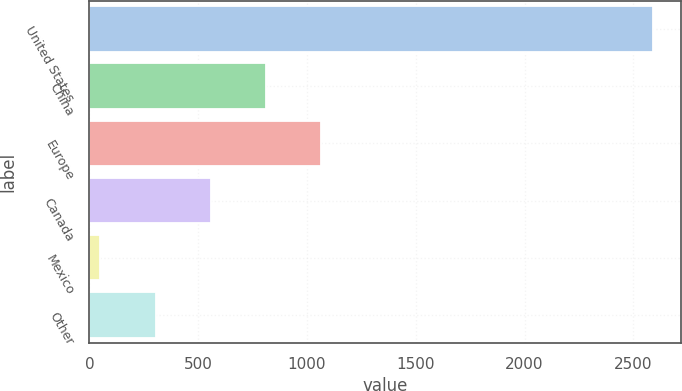Convert chart. <chart><loc_0><loc_0><loc_500><loc_500><bar_chart><fcel>United States<fcel>China<fcel>Europe<fcel>Canada<fcel>Mexico<fcel>Other<nl><fcel>2589.1<fcel>812.08<fcel>1065.94<fcel>558.22<fcel>50.5<fcel>304.36<nl></chart> 